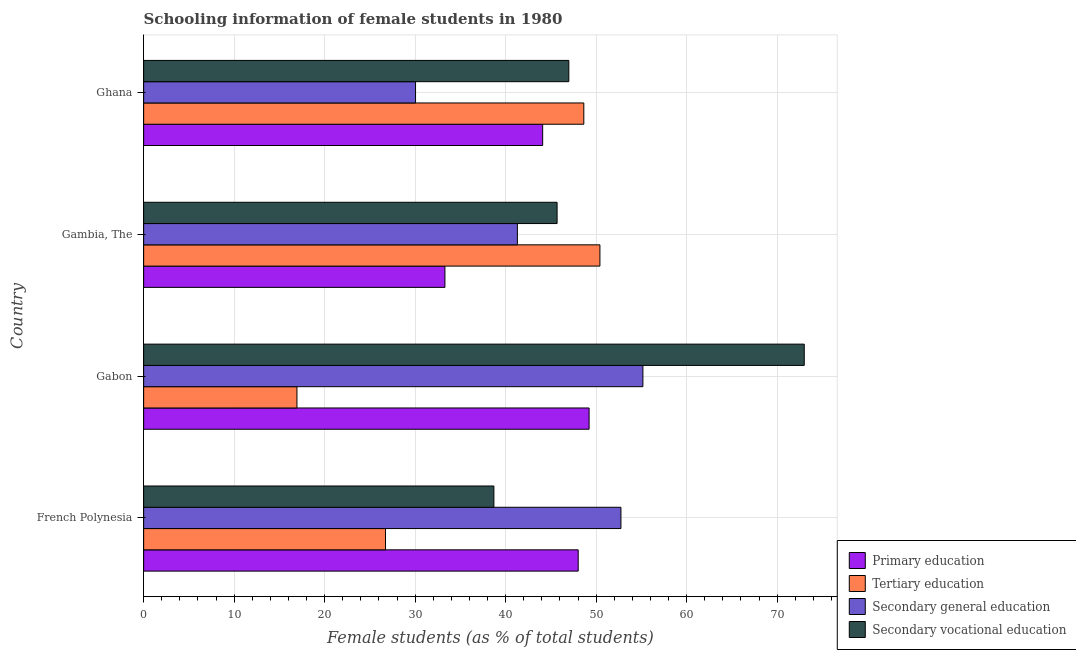How many different coloured bars are there?
Your answer should be compact. 4. How many groups of bars are there?
Give a very brief answer. 4. How many bars are there on the 1st tick from the top?
Your answer should be very brief. 4. What is the label of the 4th group of bars from the top?
Your answer should be very brief. French Polynesia. What is the percentage of female students in tertiary education in Ghana?
Make the answer very short. 48.64. Across all countries, what is the maximum percentage of female students in secondary vocational education?
Offer a very short reply. 73. Across all countries, what is the minimum percentage of female students in secondary vocational education?
Give a very brief answer. 38.7. In which country was the percentage of female students in secondary vocational education maximum?
Provide a short and direct response. Gabon. In which country was the percentage of female students in primary education minimum?
Offer a very short reply. Gambia, The. What is the total percentage of female students in secondary vocational education in the graph?
Your response must be concise. 204.37. What is the difference between the percentage of female students in secondary education in French Polynesia and that in Gabon?
Make the answer very short. -2.43. What is the difference between the percentage of female students in secondary vocational education in Ghana and the percentage of female students in primary education in French Polynesia?
Provide a short and direct response. -1.04. What is the average percentage of female students in tertiary education per country?
Offer a terse response. 35.68. What is the difference between the percentage of female students in tertiary education and percentage of female students in secondary vocational education in French Polynesia?
Your answer should be compact. -11.97. What is the ratio of the percentage of female students in primary education in Gambia, The to that in Ghana?
Your response must be concise. 0.76. Is the percentage of female students in secondary education in French Polynesia less than that in Gabon?
Keep it short and to the point. Yes. What is the difference between the highest and the second highest percentage of female students in primary education?
Offer a very short reply. 1.21. What is the difference between the highest and the lowest percentage of female students in secondary education?
Provide a succinct answer. 25.12. Is the sum of the percentage of female students in primary education in French Polynesia and Gambia, The greater than the maximum percentage of female students in tertiary education across all countries?
Ensure brevity in your answer.  Yes. What does the 3rd bar from the top in Ghana represents?
Give a very brief answer. Tertiary education. What does the 2nd bar from the bottom in Ghana represents?
Give a very brief answer. Tertiary education. Is it the case that in every country, the sum of the percentage of female students in primary education and percentage of female students in tertiary education is greater than the percentage of female students in secondary education?
Your response must be concise. Yes. What is the difference between two consecutive major ticks on the X-axis?
Give a very brief answer. 10. Does the graph contain grids?
Give a very brief answer. Yes. Where does the legend appear in the graph?
Ensure brevity in your answer.  Bottom right. How many legend labels are there?
Make the answer very short. 4. What is the title of the graph?
Provide a short and direct response. Schooling information of female students in 1980. What is the label or title of the X-axis?
Provide a short and direct response. Female students (as % of total students). What is the Female students (as % of total students) of Primary education in French Polynesia?
Provide a short and direct response. 48.02. What is the Female students (as % of total students) of Tertiary education in French Polynesia?
Keep it short and to the point. 26.73. What is the Female students (as % of total students) in Secondary general education in French Polynesia?
Offer a very short reply. 52.74. What is the Female students (as % of total students) of Secondary vocational education in French Polynesia?
Your answer should be very brief. 38.7. What is the Female students (as % of total students) of Primary education in Gabon?
Provide a succinct answer. 49.22. What is the Female students (as % of total students) in Tertiary education in Gabon?
Your answer should be very brief. 16.94. What is the Female students (as % of total students) of Secondary general education in Gabon?
Offer a very short reply. 55.17. What is the Female students (as % of total students) in Secondary vocational education in Gabon?
Ensure brevity in your answer.  73. What is the Female students (as % of total students) of Primary education in Gambia, The?
Your response must be concise. 33.29. What is the Female students (as % of total students) of Tertiary education in Gambia, The?
Offer a very short reply. 50.42. What is the Female students (as % of total students) of Secondary general education in Gambia, The?
Offer a terse response. 41.3. What is the Female students (as % of total students) in Secondary vocational education in Gambia, The?
Offer a terse response. 45.69. What is the Female students (as % of total students) in Primary education in Ghana?
Keep it short and to the point. 44.09. What is the Female students (as % of total students) of Tertiary education in Ghana?
Keep it short and to the point. 48.64. What is the Female students (as % of total students) in Secondary general education in Ghana?
Offer a terse response. 30.05. What is the Female students (as % of total students) of Secondary vocational education in Ghana?
Your response must be concise. 46.98. Across all countries, what is the maximum Female students (as % of total students) of Primary education?
Your response must be concise. 49.22. Across all countries, what is the maximum Female students (as % of total students) in Tertiary education?
Ensure brevity in your answer.  50.42. Across all countries, what is the maximum Female students (as % of total students) of Secondary general education?
Your answer should be very brief. 55.17. Across all countries, what is the maximum Female students (as % of total students) of Secondary vocational education?
Your answer should be compact. 73. Across all countries, what is the minimum Female students (as % of total students) in Primary education?
Offer a terse response. 33.29. Across all countries, what is the minimum Female students (as % of total students) in Tertiary education?
Offer a very short reply. 16.94. Across all countries, what is the minimum Female students (as % of total students) of Secondary general education?
Offer a terse response. 30.05. Across all countries, what is the minimum Female students (as % of total students) in Secondary vocational education?
Ensure brevity in your answer.  38.7. What is the total Female students (as % of total students) of Primary education in the graph?
Give a very brief answer. 174.63. What is the total Female students (as % of total students) of Tertiary education in the graph?
Ensure brevity in your answer.  142.73. What is the total Female students (as % of total students) of Secondary general education in the graph?
Offer a very short reply. 179.26. What is the total Female students (as % of total students) in Secondary vocational education in the graph?
Give a very brief answer. 204.37. What is the difference between the Female students (as % of total students) of Primary education in French Polynesia and that in Gabon?
Provide a short and direct response. -1.2. What is the difference between the Female students (as % of total students) of Tertiary education in French Polynesia and that in Gabon?
Offer a terse response. 9.79. What is the difference between the Female students (as % of total students) in Secondary general education in French Polynesia and that in Gabon?
Give a very brief answer. -2.43. What is the difference between the Female students (as % of total students) of Secondary vocational education in French Polynesia and that in Gabon?
Ensure brevity in your answer.  -34.29. What is the difference between the Female students (as % of total students) of Primary education in French Polynesia and that in Gambia, The?
Provide a short and direct response. 14.73. What is the difference between the Female students (as % of total students) in Tertiary education in French Polynesia and that in Gambia, The?
Make the answer very short. -23.69. What is the difference between the Female students (as % of total students) in Secondary general education in French Polynesia and that in Gambia, The?
Your answer should be very brief. 11.44. What is the difference between the Female students (as % of total students) of Secondary vocational education in French Polynesia and that in Gambia, The?
Offer a terse response. -6.98. What is the difference between the Female students (as % of total students) of Primary education in French Polynesia and that in Ghana?
Make the answer very short. 3.93. What is the difference between the Female students (as % of total students) in Tertiary education in French Polynesia and that in Ghana?
Give a very brief answer. -21.91. What is the difference between the Female students (as % of total students) of Secondary general education in French Polynesia and that in Ghana?
Offer a terse response. 22.7. What is the difference between the Female students (as % of total students) in Secondary vocational education in French Polynesia and that in Ghana?
Keep it short and to the point. -8.28. What is the difference between the Female students (as % of total students) of Primary education in Gabon and that in Gambia, The?
Your response must be concise. 15.93. What is the difference between the Female students (as % of total students) in Tertiary education in Gabon and that in Gambia, The?
Give a very brief answer. -33.48. What is the difference between the Female students (as % of total students) of Secondary general education in Gabon and that in Gambia, The?
Make the answer very short. 13.87. What is the difference between the Female students (as % of total students) in Secondary vocational education in Gabon and that in Gambia, The?
Make the answer very short. 27.31. What is the difference between the Female students (as % of total students) in Primary education in Gabon and that in Ghana?
Provide a succinct answer. 5.13. What is the difference between the Female students (as % of total students) in Tertiary education in Gabon and that in Ghana?
Make the answer very short. -31.7. What is the difference between the Female students (as % of total students) of Secondary general education in Gabon and that in Ghana?
Ensure brevity in your answer.  25.12. What is the difference between the Female students (as % of total students) in Secondary vocational education in Gabon and that in Ghana?
Your response must be concise. 26.01. What is the difference between the Female students (as % of total students) in Primary education in Gambia, The and that in Ghana?
Your answer should be very brief. -10.8. What is the difference between the Female students (as % of total students) in Tertiary education in Gambia, The and that in Ghana?
Make the answer very short. 1.78. What is the difference between the Female students (as % of total students) of Secondary general education in Gambia, The and that in Ghana?
Your response must be concise. 11.25. What is the difference between the Female students (as % of total students) of Secondary vocational education in Gambia, The and that in Ghana?
Provide a succinct answer. -1.3. What is the difference between the Female students (as % of total students) in Primary education in French Polynesia and the Female students (as % of total students) in Tertiary education in Gabon?
Your answer should be compact. 31.08. What is the difference between the Female students (as % of total students) in Primary education in French Polynesia and the Female students (as % of total students) in Secondary general education in Gabon?
Offer a very short reply. -7.15. What is the difference between the Female students (as % of total students) in Primary education in French Polynesia and the Female students (as % of total students) in Secondary vocational education in Gabon?
Make the answer very short. -24.98. What is the difference between the Female students (as % of total students) of Tertiary education in French Polynesia and the Female students (as % of total students) of Secondary general education in Gabon?
Provide a short and direct response. -28.44. What is the difference between the Female students (as % of total students) of Tertiary education in French Polynesia and the Female students (as % of total students) of Secondary vocational education in Gabon?
Offer a very short reply. -46.27. What is the difference between the Female students (as % of total students) of Secondary general education in French Polynesia and the Female students (as % of total students) of Secondary vocational education in Gabon?
Give a very brief answer. -20.26. What is the difference between the Female students (as % of total students) in Primary education in French Polynesia and the Female students (as % of total students) in Tertiary education in Gambia, The?
Your response must be concise. -2.4. What is the difference between the Female students (as % of total students) in Primary education in French Polynesia and the Female students (as % of total students) in Secondary general education in Gambia, The?
Your response must be concise. 6.72. What is the difference between the Female students (as % of total students) in Primary education in French Polynesia and the Female students (as % of total students) in Secondary vocational education in Gambia, The?
Provide a short and direct response. 2.33. What is the difference between the Female students (as % of total students) of Tertiary education in French Polynesia and the Female students (as % of total students) of Secondary general education in Gambia, The?
Your answer should be very brief. -14.57. What is the difference between the Female students (as % of total students) in Tertiary education in French Polynesia and the Female students (as % of total students) in Secondary vocational education in Gambia, The?
Ensure brevity in your answer.  -18.96. What is the difference between the Female students (as % of total students) in Secondary general education in French Polynesia and the Female students (as % of total students) in Secondary vocational education in Gambia, The?
Keep it short and to the point. 7.05. What is the difference between the Female students (as % of total students) of Primary education in French Polynesia and the Female students (as % of total students) of Tertiary education in Ghana?
Your answer should be very brief. -0.62. What is the difference between the Female students (as % of total students) in Primary education in French Polynesia and the Female students (as % of total students) in Secondary general education in Ghana?
Give a very brief answer. 17.97. What is the difference between the Female students (as % of total students) of Primary education in French Polynesia and the Female students (as % of total students) of Secondary vocational education in Ghana?
Your answer should be very brief. 1.04. What is the difference between the Female students (as % of total students) in Tertiary education in French Polynesia and the Female students (as % of total students) in Secondary general education in Ghana?
Provide a succinct answer. -3.32. What is the difference between the Female students (as % of total students) in Tertiary education in French Polynesia and the Female students (as % of total students) in Secondary vocational education in Ghana?
Your answer should be very brief. -20.26. What is the difference between the Female students (as % of total students) of Secondary general education in French Polynesia and the Female students (as % of total students) of Secondary vocational education in Ghana?
Provide a succinct answer. 5.76. What is the difference between the Female students (as % of total students) of Primary education in Gabon and the Female students (as % of total students) of Tertiary education in Gambia, The?
Offer a very short reply. -1.2. What is the difference between the Female students (as % of total students) in Primary education in Gabon and the Female students (as % of total students) in Secondary general education in Gambia, The?
Give a very brief answer. 7.93. What is the difference between the Female students (as % of total students) in Primary education in Gabon and the Female students (as % of total students) in Secondary vocational education in Gambia, The?
Provide a short and direct response. 3.54. What is the difference between the Female students (as % of total students) in Tertiary education in Gabon and the Female students (as % of total students) in Secondary general education in Gambia, The?
Give a very brief answer. -24.36. What is the difference between the Female students (as % of total students) in Tertiary education in Gabon and the Female students (as % of total students) in Secondary vocational education in Gambia, The?
Offer a very short reply. -28.75. What is the difference between the Female students (as % of total students) of Secondary general education in Gabon and the Female students (as % of total students) of Secondary vocational education in Gambia, The?
Offer a very short reply. 9.48. What is the difference between the Female students (as % of total students) in Primary education in Gabon and the Female students (as % of total students) in Tertiary education in Ghana?
Make the answer very short. 0.58. What is the difference between the Female students (as % of total students) of Primary education in Gabon and the Female students (as % of total students) of Secondary general education in Ghana?
Give a very brief answer. 19.18. What is the difference between the Female students (as % of total students) of Primary education in Gabon and the Female students (as % of total students) of Secondary vocational education in Ghana?
Provide a succinct answer. 2.24. What is the difference between the Female students (as % of total students) in Tertiary education in Gabon and the Female students (as % of total students) in Secondary general education in Ghana?
Offer a terse response. -13.1. What is the difference between the Female students (as % of total students) in Tertiary education in Gabon and the Female students (as % of total students) in Secondary vocational education in Ghana?
Keep it short and to the point. -30.04. What is the difference between the Female students (as % of total students) in Secondary general education in Gabon and the Female students (as % of total students) in Secondary vocational education in Ghana?
Keep it short and to the point. 8.19. What is the difference between the Female students (as % of total students) in Primary education in Gambia, The and the Female students (as % of total students) in Tertiary education in Ghana?
Make the answer very short. -15.35. What is the difference between the Female students (as % of total students) in Primary education in Gambia, The and the Female students (as % of total students) in Secondary general education in Ghana?
Keep it short and to the point. 3.25. What is the difference between the Female students (as % of total students) of Primary education in Gambia, The and the Female students (as % of total students) of Secondary vocational education in Ghana?
Offer a very short reply. -13.69. What is the difference between the Female students (as % of total students) in Tertiary education in Gambia, The and the Female students (as % of total students) in Secondary general education in Ghana?
Offer a very short reply. 20.38. What is the difference between the Female students (as % of total students) in Tertiary education in Gambia, The and the Female students (as % of total students) in Secondary vocational education in Ghana?
Provide a short and direct response. 3.44. What is the difference between the Female students (as % of total students) in Secondary general education in Gambia, The and the Female students (as % of total students) in Secondary vocational education in Ghana?
Your response must be concise. -5.69. What is the average Female students (as % of total students) in Primary education per country?
Provide a succinct answer. 43.66. What is the average Female students (as % of total students) in Tertiary education per country?
Your answer should be compact. 35.68. What is the average Female students (as % of total students) in Secondary general education per country?
Your answer should be very brief. 44.81. What is the average Female students (as % of total students) of Secondary vocational education per country?
Give a very brief answer. 51.09. What is the difference between the Female students (as % of total students) in Primary education and Female students (as % of total students) in Tertiary education in French Polynesia?
Ensure brevity in your answer.  21.29. What is the difference between the Female students (as % of total students) of Primary education and Female students (as % of total students) of Secondary general education in French Polynesia?
Your answer should be very brief. -4.72. What is the difference between the Female students (as % of total students) of Primary education and Female students (as % of total students) of Secondary vocational education in French Polynesia?
Offer a terse response. 9.32. What is the difference between the Female students (as % of total students) of Tertiary education and Female students (as % of total students) of Secondary general education in French Polynesia?
Give a very brief answer. -26.01. What is the difference between the Female students (as % of total students) in Tertiary education and Female students (as % of total students) in Secondary vocational education in French Polynesia?
Give a very brief answer. -11.98. What is the difference between the Female students (as % of total students) of Secondary general education and Female students (as % of total students) of Secondary vocational education in French Polynesia?
Offer a very short reply. 14.04. What is the difference between the Female students (as % of total students) in Primary education and Female students (as % of total students) in Tertiary education in Gabon?
Provide a succinct answer. 32.28. What is the difference between the Female students (as % of total students) in Primary education and Female students (as % of total students) in Secondary general education in Gabon?
Ensure brevity in your answer.  -5.95. What is the difference between the Female students (as % of total students) of Primary education and Female students (as % of total students) of Secondary vocational education in Gabon?
Give a very brief answer. -23.77. What is the difference between the Female students (as % of total students) in Tertiary education and Female students (as % of total students) in Secondary general education in Gabon?
Provide a short and direct response. -38.23. What is the difference between the Female students (as % of total students) of Tertiary education and Female students (as % of total students) of Secondary vocational education in Gabon?
Ensure brevity in your answer.  -56.06. What is the difference between the Female students (as % of total students) of Secondary general education and Female students (as % of total students) of Secondary vocational education in Gabon?
Offer a terse response. -17.83. What is the difference between the Female students (as % of total students) in Primary education and Female students (as % of total students) in Tertiary education in Gambia, The?
Provide a short and direct response. -17.13. What is the difference between the Female students (as % of total students) in Primary education and Female students (as % of total students) in Secondary general education in Gambia, The?
Keep it short and to the point. -8.01. What is the difference between the Female students (as % of total students) in Primary education and Female students (as % of total students) in Secondary vocational education in Gambia, The?
Give a very brief answer. -12.39. What is the difference between the Female students (as % of total students) of Tertiary education and Female students (as % of total students) of Secondary general education in Gambia, The?
Make the answer very short. 9.12. What is the difference between the Female students (as % of total students) of Tertiary education and Female students (as % of total students) of Secondary vocational education in Gambia, The?
Provide a short and direct response. 4.73. What is the difference between the Female students (as % of total students) in Secondary general education and Female students (as % of total students) in Secondary vocational education in Gambia, The?
Keep it short and to the point. -4.39. What is the difference between the Female students (as % of total students) of Primary education and Female students (as % of total students) of Tertiary education in Ghana?
Give a very brief answer. -4.55. What is the difference between the Female students (as % of total students) of Primary education and Female students (as % of total students) of Secondary general education in Ghana?
Make the answer very short. 14.05. What is the difference between the Female students (as % of total students) in Primary education and Female students (as % of total students) in Secondary vocational education in Ghana?
Ensure brevity in your answer.  -2.89. What is the difference between the Female students (as % of total students) of Tertiary education and Female students (as % of total students) of Secondary general education in Ghana?
Keep it short and to the point. 18.59. What is the difference between the Female students (as % of total students) of Tertiary education and Female students (as % of total students) of Secondary vocational education in Ghana?
Your answer should be very brief. 1.66. What is the difference between the Female students (as % of total students) of Secondary general education and Female students (as % of total students) of Secondary vocational education in Ghana?
Ensure brevity in your answer.  -16.94. What is the ratio of the Female students (as % of total students) in Primary education in French Polynesia to that in Gabon?
Provide a succinct answer. 0.98. What is the ratio of the Female students (as % of total students) of Tertiary education in French Polynesia to that in Gabon?
Offer a very short reply. 1.58. What is the ratio of the Female students (as % of total students) of Secondary general education in French Polynesia to that in Gabon?
Provide a short and direct response. 0.96. What is the ratio of the Female students (as % of total students) of Secondary vocational education in French Polynesia to that in Gabon?
Give a very brief answer. 0.53. What is the ratio of the Female students (as % of total students) in Primary education in French Polynesia to that in Gambia, The?
Provide a succinct answer. 1.44. What is the ratio of the Female students (as % of total students) in Tertiary education in French Polynesia to that in Gambia, The?
Provide a succinct answer. 0.53. What is the ratio of the Female students (as % of total students) of Secondary general education in French Polynesia to that in Gambia, The?
Your response must be concise. 1.28. What is the ratio of the Female students (as % of total students) of Secondary vocational education in French Polynesia to that in Gambia, The?
Make the answer very short. 0.85. What is the ratio of the Female students (as % of total students) in Primary education in French Polynesia to that in Ghana?
Offer a terse response. 1.09. What is the ratio of the Female students (as % of total students) in Tertiary education in French Polynesia to that in Ghana?
Keep it short and to the point. 0.55. What is the ratio of the Female students (as % of total students) in Secondary general education in French Polynesia to that in Ghana?
Your answer should be compact. 1.76. What is the ratio of the Female students (as % of total students) in Secondary vocational education in French Polynesia to that in Ghana?
Give a very brief answer. 0.82. What is the ratio of the Female students (as % of total students) of Primary education in Gabon to that in Gambia, The?
Ensure brevity in your answer.  1.48. What is the ratio of the Female students (as % of total students) of Tertiary education in Gabon to that in Gambia, The?
Your answer should be compact. 0.34. What is the ratio of the Female students (as % of total students) of Secondary general education in Gabon to that in Gambia, The?
Provide a short and direct response. 1.34. What is the ratio of the Female students (as % of total students) of Secondary vocational education in Gabon to that in Gambia, The?
Keep it short and to the point. 1.6. What is the ratio of the Female students (as % of total students) of Primary education in Gabon to that in Ghana?
Your answer should be very brief. 1.12. What is the ratio of the Female students (as % of total students) of Tertiary education in Gabon to that in Ghana?
Provide a short and direct response. 0.35. What is the ratio of the Female students (as % of total students) of Secondary general education in Gabon to that in Ghana?
Your answer should be very brief. 1.84. What is the ratio of the Female students (as % of total students) in Secondary vocational education in Gabon to that in Ghana?
Your answer should be compact. 1.55. What is the ratio of the Female students (as % of total students) of Primary education in Gambia, The to that in Ghana?
Your answer should be very brief. 0.76. What is the ratio of the Female students (as % of total students) of Tertiary education in Gambia, The to that in Ghana?
Your answer should be very brief. 1.04. What is the ratio of the Female students (as % of total students) of Secondary general education in Gambia, The to that in Ghana?
Provide a short and direct response. 1.37. What is the ratio of the Female students (as % of total students) of Secondary vocational education in Gambia, The to that in Ghana?
Your answer should be very brief. 0.97. What is the difference between the highest and the second highest Female students (as % of total students) of Primary education?
Keep it short and to the point. 1.2. What is the difference between the highest and the second highest Female students (as % of total students) in Tertiary education?
Make the answer very short. 1.78. What is the difference between the highest and the second highest Female students (as % of total students) of Secondary general education?
Offer a very short reply. 2.43. What is the difference between the highest and the second highest Female students (as % of total students) of Secondary vocational education?
Keep it short and to the point. 26.01. What is the difference between the highest and the lowest Female students (as % of total students) of Primary education?
Your response must be concise. 15.93. What is the difference between the highest and the lowest Female students (as % of total students) of Tertiary education?
Your response must be concise. 33.48. What is the difference between the highest and the lowest Female students (as % of total students) in Secondary general education?
Offer a terse response. 25.12. What is the difference between the highest and the lowest Female students (as % of total students) in Secondary vocational education?
Your response must be concise. 34.29. 